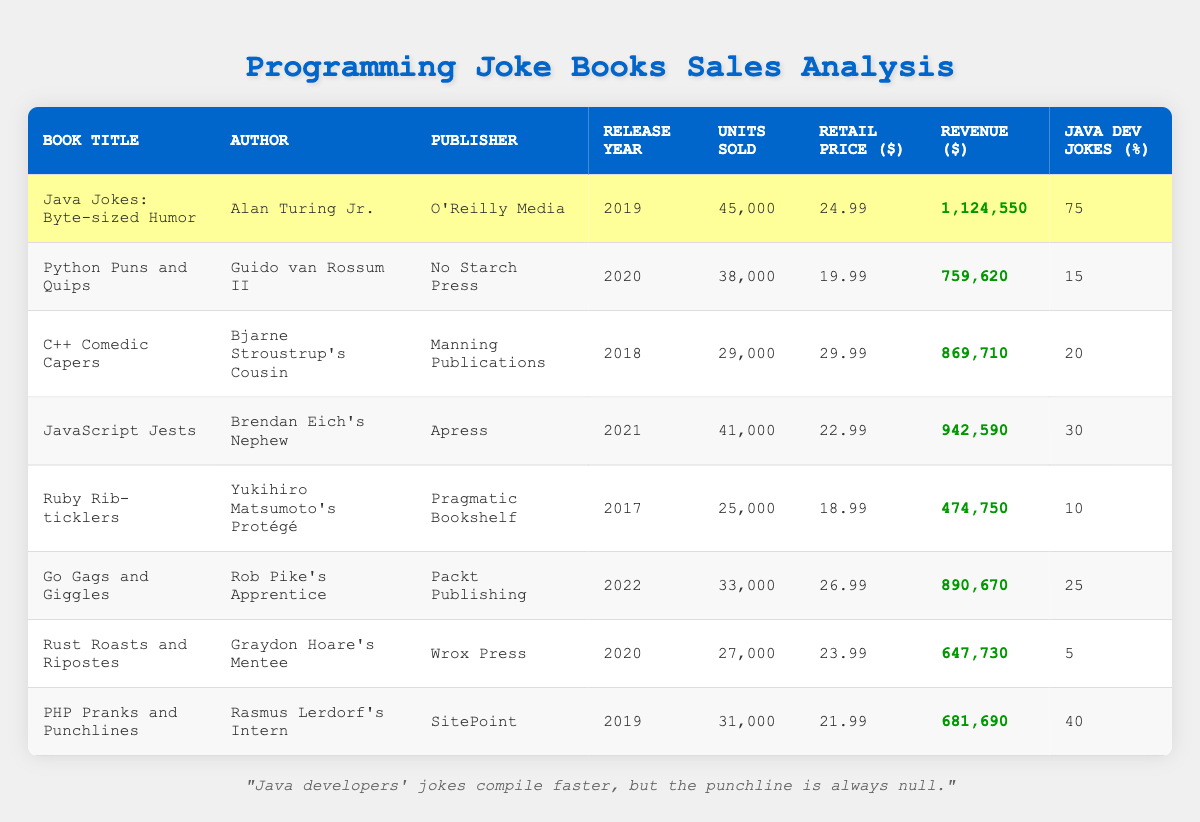What is the total revenue generated by all the joke books? To find the total revenue, we need to sum up all the revenue values: 1,124,550 + 759,620 + 869,710 + 942,590 + 474,750 + 890,670 + 647,730 + 681,690 = 5,490,660.
Answer: 5,490,660 Which book has the highest percentage of Java developer jokes? By looking at the 'Java Dev Jokes (%)' column, we can see that "Java Jokes: Byte-sized Humor" has the highest percentage at 75%.
Answer: Java Jokes: Byte-sized Humor Is it true that all books published after 2019 have sold more than 30,000 units? Examining the books released after 2019: "Python Puns and Quips" (38,000), "JavaScript Jests" (41,000), "Go Gags and Giggles" (33,000), and "Rust Roasts and Ripostes" (27,000). The last book sold 27,000 units, which is less than 30,000. Therefore, the statement is false.
Answer: No What book generated the least revenue? We look at the 'Revenue ($)' column and determine which value is the smallest. "Ruby Rib-ticklers" generated the least revenue at 474,750.
Answer: Ruby Rib-ticklers What is the average retail price of the joke books? To find the average retail price, sum the retail prices: 24.99 + 19.99 + 29.99 + 22.99 + 18.99 + 26.99 + 23.99 + 21.99 = 198.92. There are 8 books, so the average is 198.92 / 8 = 24.86.
Answer: 24.86 How many units did "PHP Pranks and Punchlines" sell more than "Rust Roasts and Ripostes"? "PHP Pranks and Punchlines" sold 31,000 units while "Rust Roasts and Ripostes" sold 27,000 units. The difference is 31,000 - 27,000 = 4,000 units.
Answer: 4,000 Which author has written the most units sold across their books? From the table, we see authors with sold units: Alan Turing Jr. (45,000), Guido van Rossum II (38,000), Bjarne Stroustrup's Cousin (29,000), Brendan Eich's Nephew (41,000), Yukihiro Matsumoto's Protégé (25,000), Rob Pike's Apprentice (33,000), Graydon Hoare's Mentee (27,000), Rasmus Lerdorf's Intern (31,000). Total for Guido van Rossum II = 38,000 is the highest among the unique authors.
Answer: Alan Turing Jr Are there more books with above-average revenue than below-average revenue? We first calculate the average revenue, which is total revenue 5,490,660 divided by 8 equals to 686,332.5. The above-average books are 1,124,550, 759,620, 869,710, 942,590, 890,670, 681,690, and those below average are "Rust Roasts and Ripostes" (647,730 revenue) and "Ruby Rib-ticklers" (474,750 revenue). Hence, there are more above-average books (6) than below-average (2).
Answer: Yes 